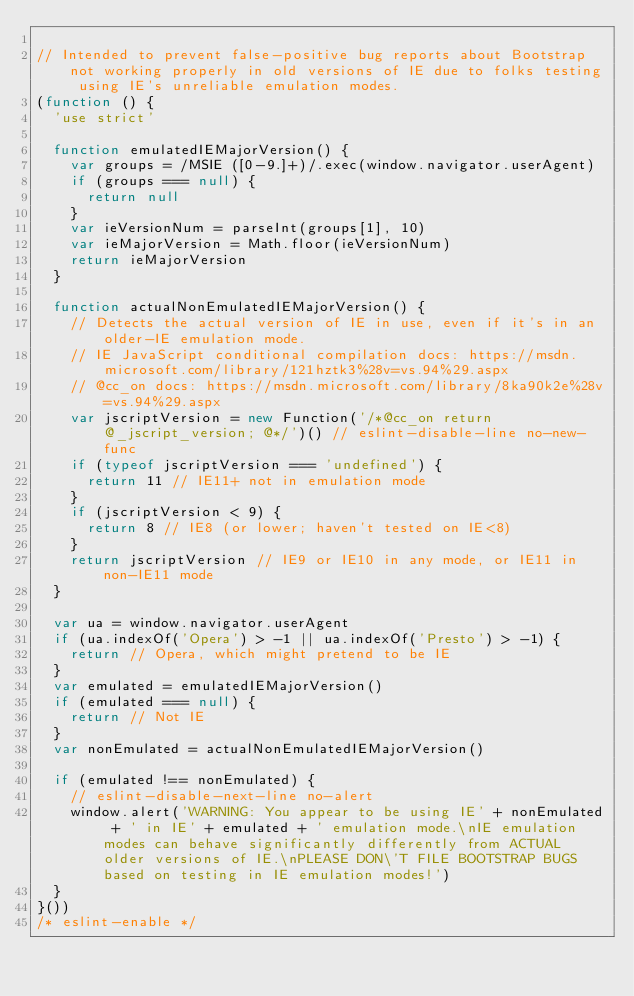<code> <loc_0><loc_0><loc_500><loc_500><_JavaScript_>
// Intended to prevent false-positive bug reports about Bootstrap not working properly in old versions of IE due to folks testing using IE's unreliable emulation modes.
(function () {
  'use strict'

  function emulatedIEMajorVersion() {
    var groups = /MSIE ([0-9.]+)/.exec(window.navigator.userAgent)
    if (groups === null) {
      return null
    }
    var ieVersionNum = parseInt(groups[1], 10)
    var ieMajorVersion = Math.floor(ieVersionNum)
    return ieMajorVersion
  }

  function actualNonEmulatedIEMajorVersion() {
    // Detects the actual version of IE in use, even if it's in an older-IE emulation mode.
    // IE JavaScript conditional compilation docs: https://msdn.microsoft.com/library/121hztk3%28v=vs.94%29.aspx
    // @cc_on docs: https://msdn.microsoft.com/library/8ka90k2e%28v=vs.94%29.aspx
    var jscriptVersion = new Function('/*@cc_on return @_jscript_version; @*/')() // eslint-disable-line no-new-func
    if (typeof jscriptVersion === 'undefined') {
      return 11 // IE11+ not in emulation mode
    }
    if (jscriptVersion < 9) {
      return 8 // IE8 (or lower; haven't tested on IE<8)
    }
    return jscriptVersion // IE9 or IE10 in any mode, or IE11 in non-IE11 mode
  }

  var ua = window.navigator.userAgent
  if (ua.indexOf('Opera') > -1 || ua.indexOf('Presto') > -1) {
    return // Opera, which might pretend to be IE
  }
  var emulated = emulatedIEMajorVersion()
  if (emulated === null) {
    return // Not IE
  }
  var nonEmulated = actualNonEmulatedIEMajorVersion()

  if (emulated !== nonEmulated) {
    // eslint-disable-next-line no-alert
    window.alert('WARNING: You appear to be using IE' + nonEmulated + ' in IE' + emulated + ' emulation mode.\nIE emulation modes can behave significantly differently from ACTUAL older versions of IE.\nPLEASE DON\'T FILE BOOTSTRAP BUGS based on testing in IE emulation modes!')
  }
}())
/* eslint-enable */
</code> 